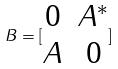Convert formula to latex. <formula><loc_0><loc_0><loc_500><loc_500>B = [ \begin{matrix} 0 & A ^ { * } \\ A & 0 \end{matrix} ]</formula> 